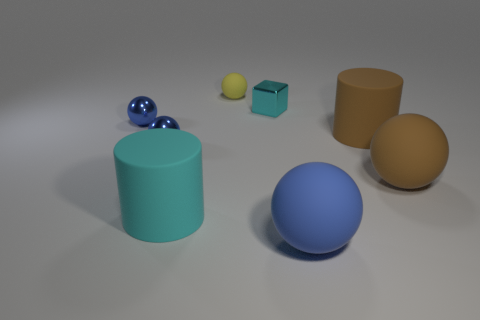Subtract all purple cylinders. How many blue spheres are left? 3 Subtract all gray balls. Subtract all blue cylinders. How many balls are left? 5 Add 1 cyan blocks. How many objects exist? 9 Subtract all cubes. How many objects are left? 7 Subtract 1 cyan cubes. How many objects are left? 7 Subtract all small blue objects. Subtract all small yellow things. How many objects are left? 5 Add 8 small rubber objects. How many small rubber objects are left? 9 Add 6 large rubber objects. How many large rubber objects exist? 10 